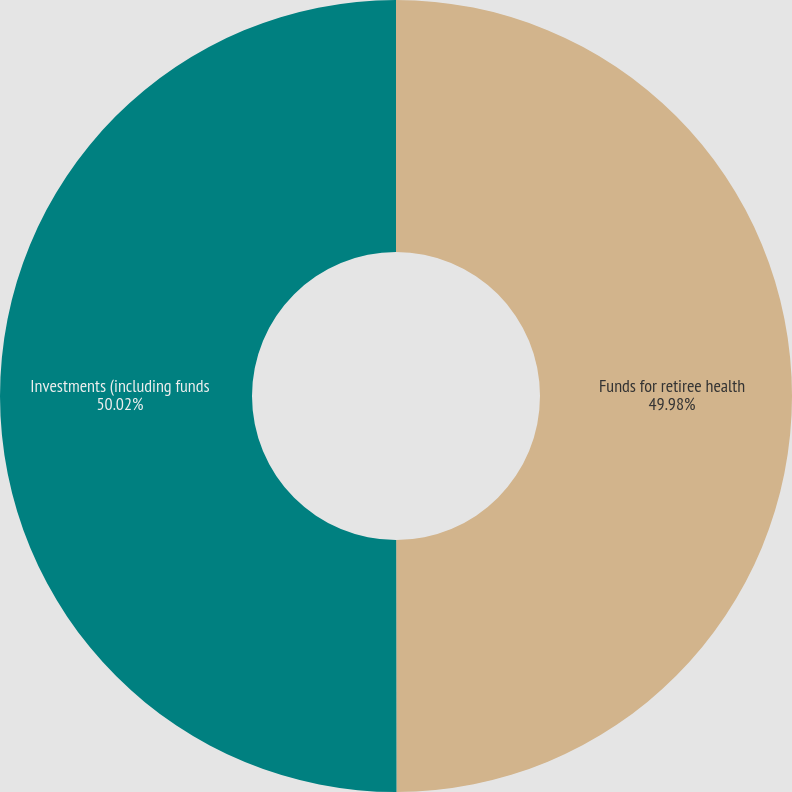<chart> <loc_0><loc_0><loc_500><loc_500><pie_chart><fcel>Funds for retiree health<fcel>Investments (including funds<nl><fcel>49.98%<fcel>50.02%<nl></chart> 